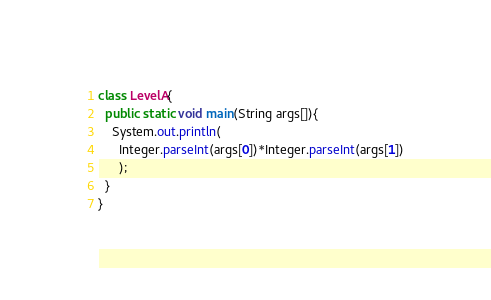<code> <loc_0><loc_0><loc_500><loc_500><_Java_>
class LevelA{
  public static void main(String args[]){
    System.out.println(
      Integer.parseInt(args[0])*Integer.parseInt(args[1])
      );
  }
}</code> 